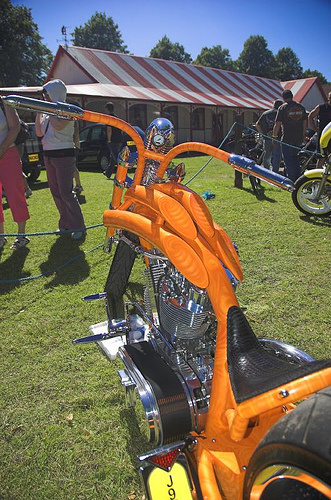<image>
Is there a hat next to the motorcycle? No. The hat is not positioned next to the motorcycle. They are located in different areas of the scene. Is there a black car in front of the motorcycle? No. The black car is not in front of the motorcycle. The spatial positioning shows a different relationship between these objects. 